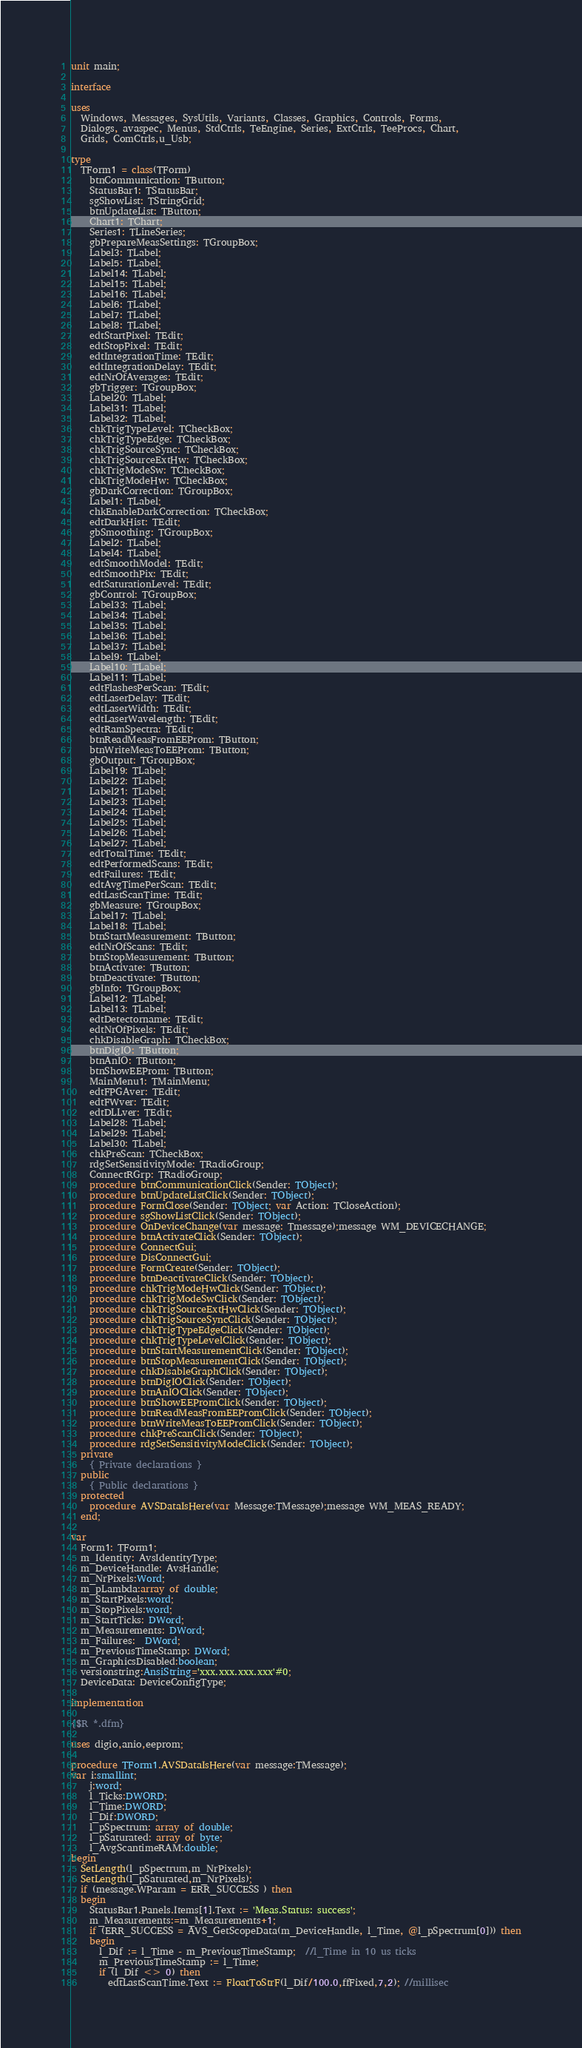Convert code to text. <code><loc_0><loc_0><loc_500><loc_500><_Pascal_>unit main;

interface

uses
  Windows, Messages, SysUtils, Variants, Classes, Graphics, Controls, Forms,
  Dialogs, avaspec, Menus, StdCtrls, TeEngine, Series, ExtCtrls, TeeProcs, Chart,
  Grids, ComCtrls,u_Usb;

type
  TForm1 = class(TForm)
    btnCommunication: TButton;
    StatusBar1: TStatusBar;
    sgShowList: TStringGrid;
    btnUpdateList: TButton;
    Chart1: TChart;
    Series1: TLineSeries;
    gbPrepareMeasSettings: TGroupBox;
    Label3: TLabel;
    Label5: TLabel;
    Label14: TLabel;
    Label15: TLabel;
    Label16: TLabel;
    Label6: TLabel;
    Label7: TLabel;
    Label8: TLabel;
    edtStartPixel: TEdit;
    edtStopPixel: TEdit;
    edtIntegrationTime: TEdit;
    edtIntegrationDelay: TEdit;
    edtNrOfAverages: TEdit;
    gbTrigger: TGroupBox;
    Label20: TLabel;
    Label31: TLabel;
    Label32: TLabel;
    chkTrigTypeLevel: TCheckBox;
    chkTrigTypeEdge: TCheckBox;
    chkTrigSourceSync: TCheckBox;
    chkTrigSourceExtHw: TCheckBox;
    chkTrigModeSw: TCheckBox;
    chkTrigModeHw: TCheckBox;
    gbDarkCorrection: TGroupBox;
    Label1: TLabel;
    chkEnableDarkCorrection: TCheckBox;
    edtDarkHist: TEdit;
    gbSmoothing: TGroupBox;
    Label2: TLabel;
    Label4: TLabel;
    edtSmoothModel: TEdit;
    edtSmoothPix: TEdit;
    edtSaturationLevel: TEdit;
    gbControl: TGroupBox;
    Label33: TLabel;
    Label34: TLabel;
    Label35: TLabel;
    Label36: TLabel;
    Label37: TLabel;
    Label9: TLabel;
    Label10: TLabel;
    Label11: TLabel;
    edtFlashesPerScan: TEdit;
    edtLaserDelay: TEdit;
    edtLaserWidth: TEdit;
    edtLaserWavelength: TEdit;
    edtRamSpectra: TEdit;
    btnReadMeasFromEEProm: TButton;
    btnWriteMeasToEEProm: TButton;
    gbOutput: TGroupBox;
    Label19: TLabel;
    Label22: TLabel;
    Label21: TLabel;
    Label23: TLabel;
    Label24: TLabel;
    Label25: TLabel;
    Label26: TLabel;
    Label27: TLabel;
    edtTotalTime: TEdit;
    edtPerformedScans: TEdit;
    edtFailures: TEdit;
    edtAvgTimePerScan: TEdit;
    edtLastScanTime: TEdit;
    gbMeasure: TGroupBox;
    Label17: TLabel;
    Label18: TLabel;
    btnStartMeasurement: TButton;
    edtNrOfScans: TEdit;
    btnStopMeasurement: TButton;
    btnActivate: TButton;
    btnDeactivate: TButton;
    gbInfo: TGroupBox;
    Label12: TLabel;
    Label13: TLabel;
    edtDetectorname: TEdit;
    edtNrOfPixels: TEdit;
    chkDisableGraph: TCheckBox;
    btnDigIO: TButton;
    btnAnIO: TButton;
    btnShowEEProm: TButton;
    MainMenu1: TMainMenu;
    edtFPGAver: TEdit;
    edtFWver: TEdit;
    edtDLLver: TEdit;
    Label28: TLabel;
    Label29: TLabel;
    Label30: TLabel;
    chkPreScan: TCheckBox;
    rdgSetSensitivityMode: TRadioGroup;
    ConnectRGrp: TRadioGroup;
    procedure btnCommunicationClick(Sender: TObject);
    procedure btnUpdateListClick(Sender: TObject);
    procedure FormClose(Sender: TObject; var Action: TCloseAction);
    procedure sgShowListClick(Sender: TObject);
    procedure OnDeviceChange(var message: Tmessage);message WM_DEVICECHANGE;
    procedure btnActivateClick(Sender: TObject);
    procedure ConnectGui;
    procedure DisConnectGui;
    procedure FormCreate(Sender: TObject);
    procedure btnDeactivateClick(Sender: TObject);
    procedure chkTrigModeHwClick(Sender: TObject);
    procedure chkTrigModeSwClick(Sender: TObject);
    procedure chkTrigSourceExtHwClick(Sender: TObject);
    procedure chkTrigSourceSyncClick(Sender: TObject);
    procedure chkTrigTypeEdgeClick(Sender: TObject);
    procedure chkTrigTypeLevelClick(Sender: TObject);
    procedure btnStartMeasurementClick(Sender: TObject);
    procedure btnStopMeasurementClick(Sender: TObject);
    procedure chkDisableGraphClick(Sender: TObject);
    procedure btnDigIOClick(Sender: TObject);
    procedure btnAnIOClick(Sender: TObject);
    procedure btnShowEEPromClick(Sender: TObject);
    procedure btnReadMeasFromEEPromClick(Sender: TObject);
    procedure btnWriteMeasToEEPromClick(Sender: TObject);
    procedure chkPreScanClick(Sender: TObject);
    procedure rdgSetSensitivityModeClick(Sender: TObject);
  private
    { Private declarations }
  public
    { Public declarations }
  protected
    procedure AVSDataIsHere(var Message:TMessage);message WM_MEAS_READY;
  end;

var
  Form1: TForm1;
  m_Identity: AvsIdentityType;
  m_DeviceHandle: AvsHandle;
  m_NrPixels:Word;
  m_pLambda:array of double;
  m_StartPixels:word;
  m_StopPixels:word;
  m_StartTicks: DWord;
  m_Measurements: DWord;
  m_Failures:  DWord;
  m_PreviousTimeStamp: DWord;
  m_GraphicsDisabled:boolean;
  versionstring:AnsiString='xxx.xxx.xxx.xxx'#0;
  DeviceData: DeviceConfigType;

implementation

{$R *.dfm}

uses digio,anio,eeprom;

procedure TForm1.AVSDataIsHere(var message:TMessage);
var i:smallint;
    j:word;
    l_Ticks:DWORD;
    l_Time:DWORD;
    l_Dif:DWORD;
    l_pSpectrum: array of double;
    l_pSaturated: array of byte;
    l_AvgScantimeRAM:double;
begin
  SetLength(l_pSpectrum,m_NrPixels);
  SetLength(l_pSaturated,m_NrPixels);
  if (message.WParam = ERR_SUCCESS ) then
  begin
    StatusBar1.Panels.Items[1].Text := 'Meas.Status: success';
    m_Measurements:=m_Measurements+1;
    if (ERR_SUCCESS = AVS_GetScopeData(m_DeviceHandle, l_Time, @l_pSpectrum[0])) then
    begin
      l_Dif := l_Time - m_PreviousTimeStamp;  //l_Time in 10 us ticks
      m_PreviousTimeStamp := l_Time;
      if (l_Dif <> 0) then
        edtLastScanTime.Text := FloatToStrF(l_Dif/100.0,ffFixed,7,2); //millisec</code> 